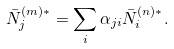<formula> <loc_0><loc_0><loc_500><loc_500>\bar { N } _ { j } ^ { ( m ) * } = \sum _ { i } \alpha _ { j i } \bar { N } _ { i } ^ { ( n ) * } .</formula> 